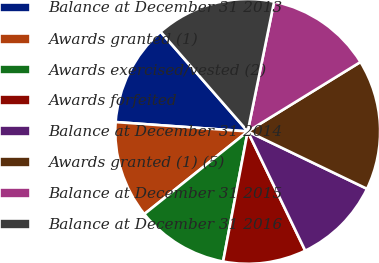Convert chart to OTSL. <chart><loc_0><loc_0><loc_500><loc_500><pie_chart><fcel>Balance at December 31 2013<fcel>Awards granted (1)<fcel>Awards exercised/vested (2)<fcel>Awards forfeited<fcel>Balance at December 31 2014<fcel>Awards granted (1) (5)<fcel>Balance at December 31 2015<fcel>Balance at December 31 2016<nl><fcel>12.44%<fcel>11.86%<fcel>11.29%<fcel>10.13%<fcel>10.71%<fcel>15.92%<fcel>13.02%<fcel>14.63%<nl></chart> 